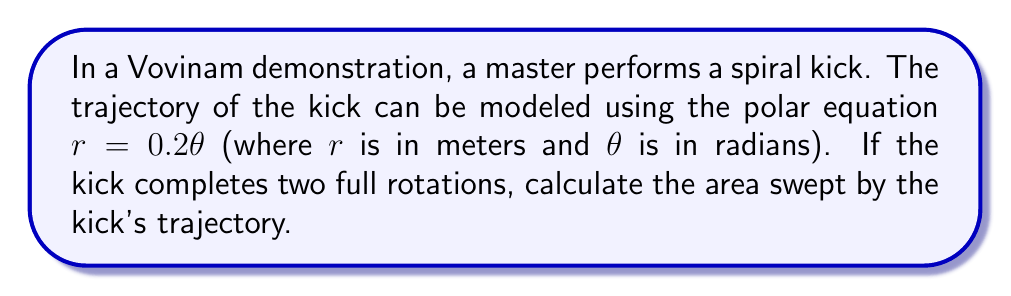Provide a solution to this math problem. To solve this problem, we'll use the formula for the area of a region in polar coordinates:

$$A = \frac{1}{2} \int_a^b r^2(\theta) d\theta$$

Where $a$ and $b$ are the starting and ending angles respectively.

Given:
- The polar equation of the trajectory: $r = 0.2\theta$
- The kick completes two full rotations, so $\theta$ goes from 0 to $4\pi$ radians

Steps:
1) Substitute the given equation into the area formula:
   $$A = \frac{1}{2} \int_0^{4\pi} (0.2\theta)^2 d\theta$$

2) Simplify the integrand:
   $$A = \frac{1}{2} \int_0^{4\pi} 0.04\theta^2 d\theta$$

3) Integrate:
   $$A = \frac{1}{2} \cdot 0.04 \cdot \left[\frac{1}{3}\theta^3\right]_0^{4\pi}$$

4) Evaluate the integral:
   $$A = 0.02 \cdot \left(\frac{1}{3}(4\pi)^3 - 0\right)$$
   $$A = \frac{0.02}{3}(64\pi^3)$$
   $$A = \frac{64\pi^3}{150} \approx 8.4823 \text{ m}^2$$

[asy]
import graph;
size(200);

real r(real t) {return 0.2*t;}
draw(polargraph(r,0,4pi),Arrow);
draw(scale(0.2)*unitcircle, dashed);
draw(scale(0.4)*unitcircle, dashed);
draw(scale(0.6)*unitcircle, dashed);
draw(scale(0.8)*unitcircle, dashed);

label("$\theta=0$", (1,0), E);
label("$\theta=2\pi$", (-1,0), W);
label("$\theta=4\pi$", (0,-1), S);
[/asy]
Answer: The area swept by the kick's trajectory is $\frac{64\pi^3}{150} \approx 8.4823 \text{ m}^2$. 